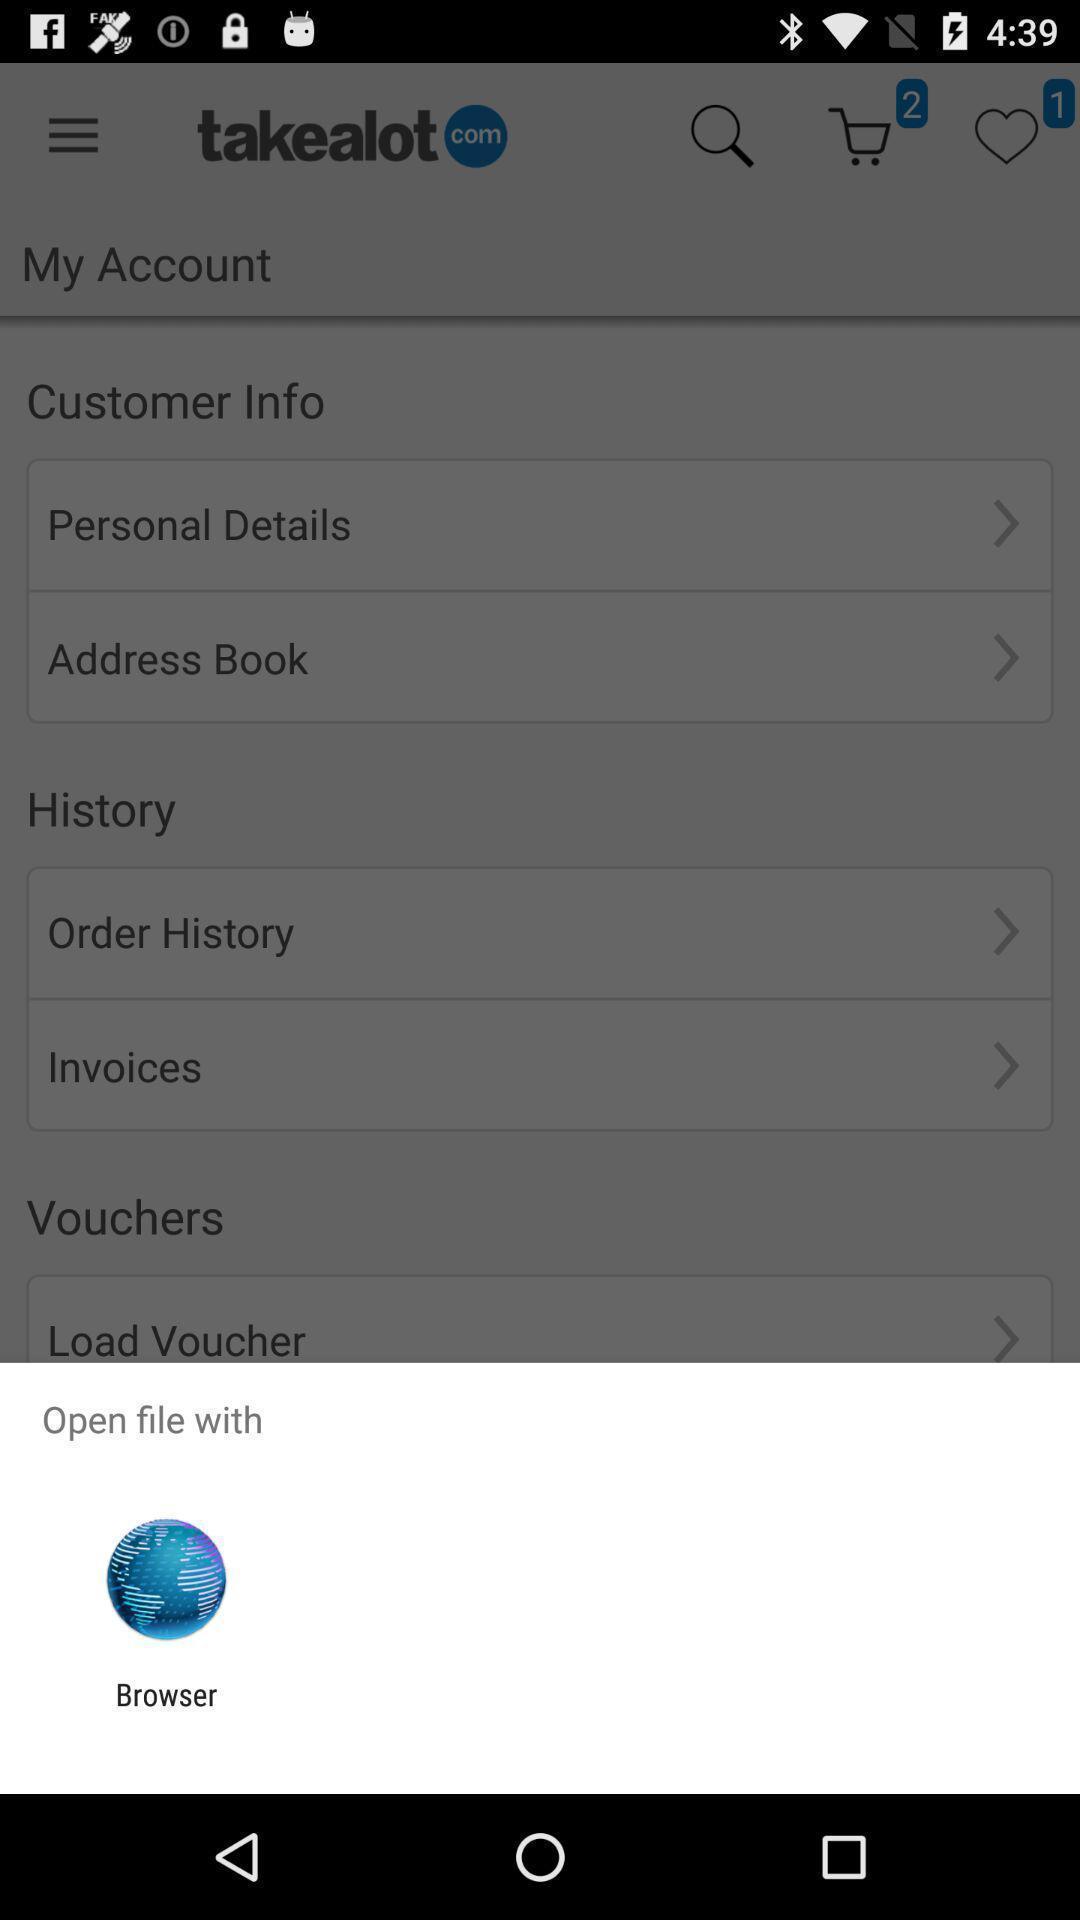What can you discern from this picture? Pop-up asking to open the file with the browser. 